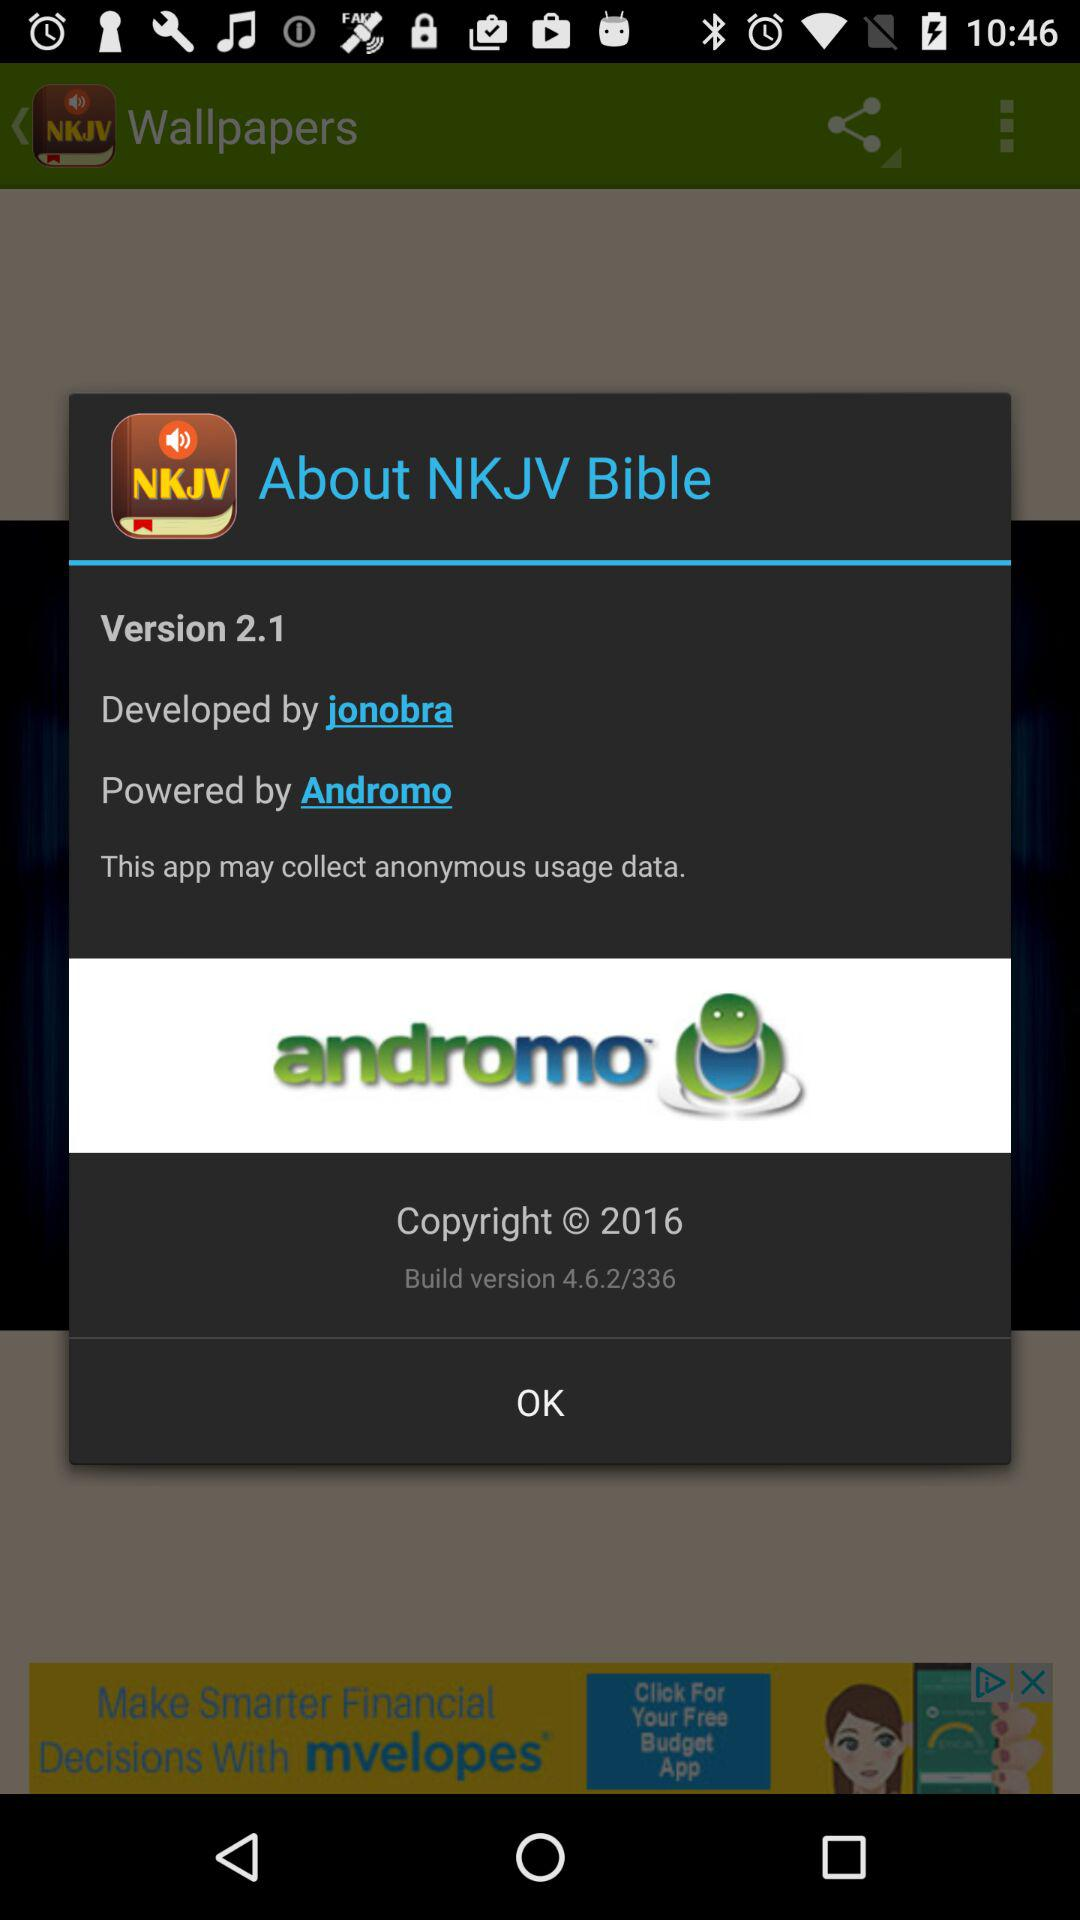What company has developed the "NKJV Bible" application? The company that has developed the "NKJV Bible" application is Jonobra. 